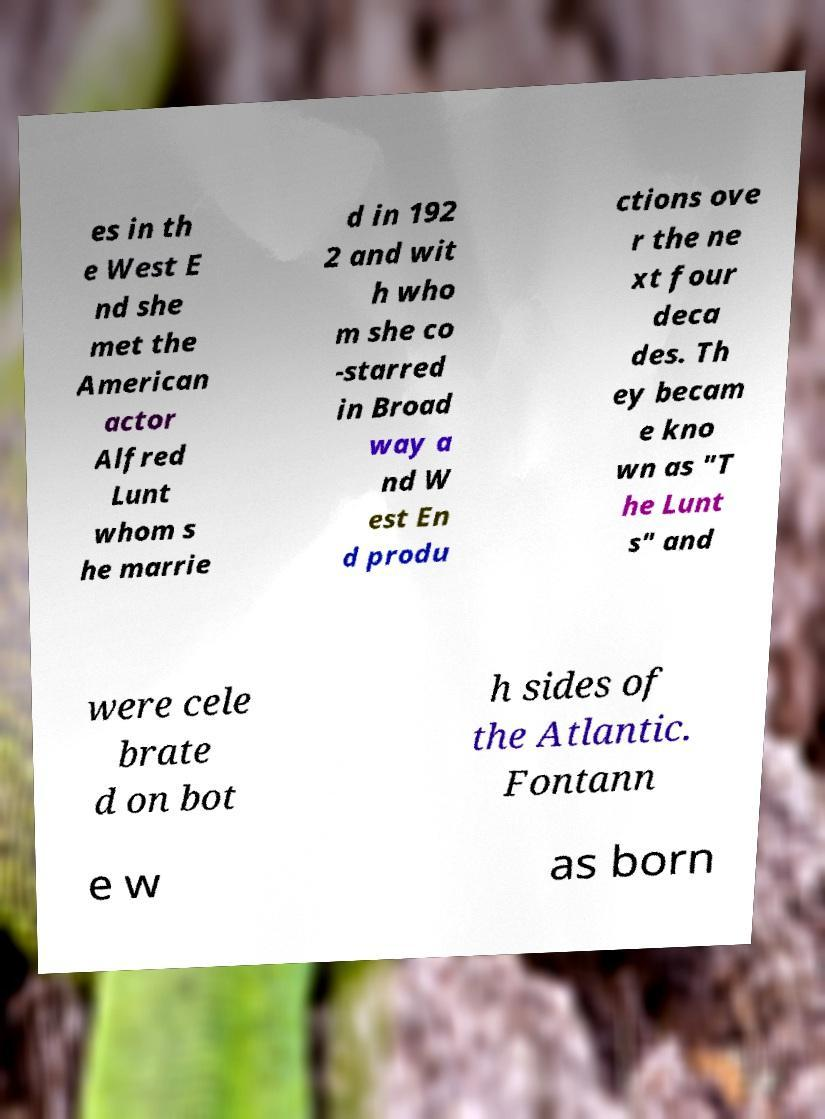Can you read and provide the text displayed in the image?This photo seems to have some interesting text. Can you extract and type it out for me? es in th e West E nd she met the American actor Alfred Lunt whom s he marrie d in 192 2 and wit h who m she co -starred in Broad way a nd W est En d produ ctions ove r the ne xt four deca des. Th ey becam e kno wn as "T he Lunt s" and were cele brate d on bot h sides of the Atlantic. Fontann e w as born 